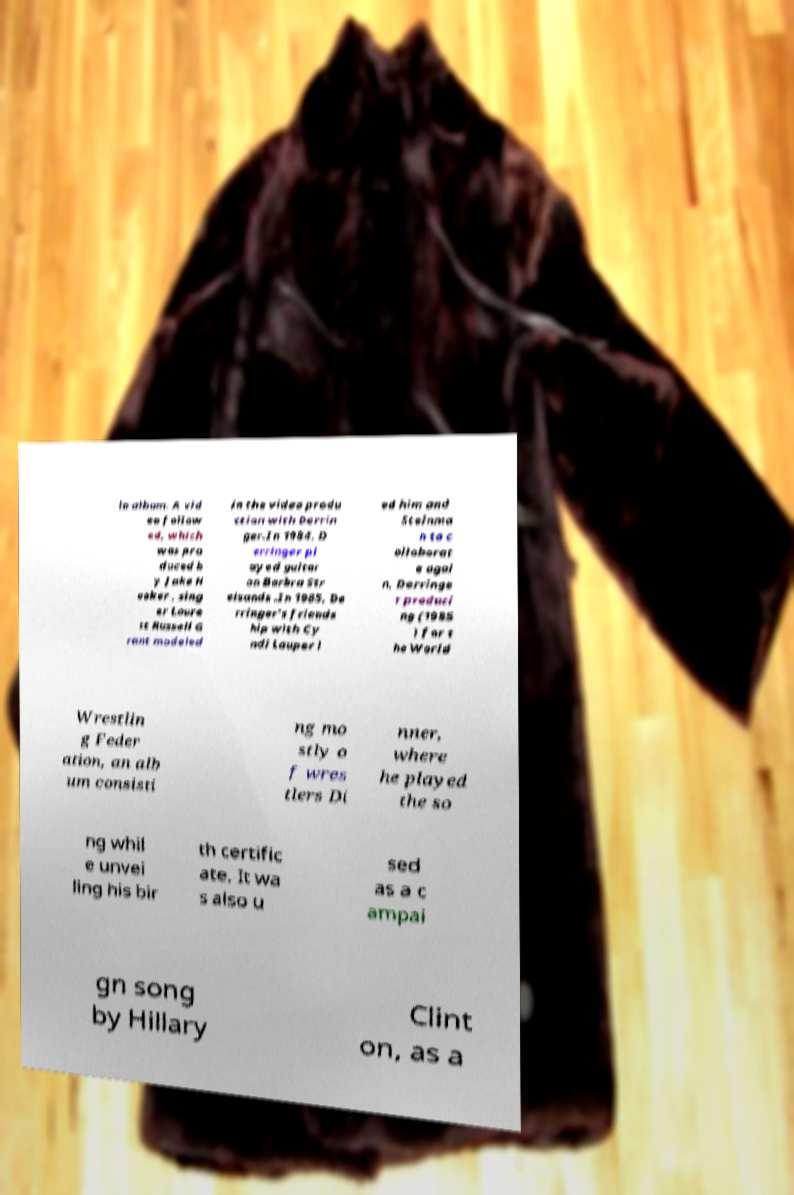I need the written content from this picture converted into text. Can you do that? lo album. A vid eo follow ed, which was pro duced b y Jake H ooker , sing er Loure tt Russell G rant modeled in the video produ ction with Derrin ger.In 1984, D erringer pl ayed guitar on Barbra Str eisands .In 1985, De rringer's friends hip with Cy ndi Lauper l ed him and Steinma n to c ollaborat e agai n, Derringe r produci ng (1985 ) for t he World Wrestlin g Feder ation, an alb um consisti ng mo stly o f wres tlers Di nner, where he played the so ng whil e unvei ling his bir th certific ate. It wa s also u sed as a c ampai gn song by Hillary Clint on, as a 